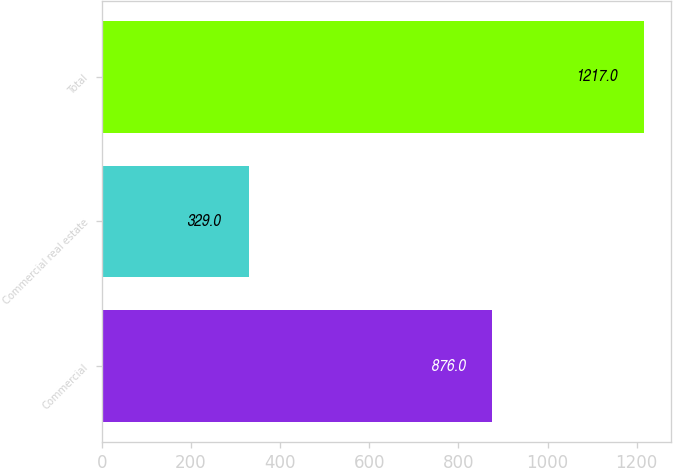Convert chart. <chart><loc_0><loc_0><loc_500><loc_500><bar_chart><fcel>Commercial<fcel>Commercial real estate<fcel>Total<nl><fcel>876<fcel>329<fcel>1217<nl></chart> 